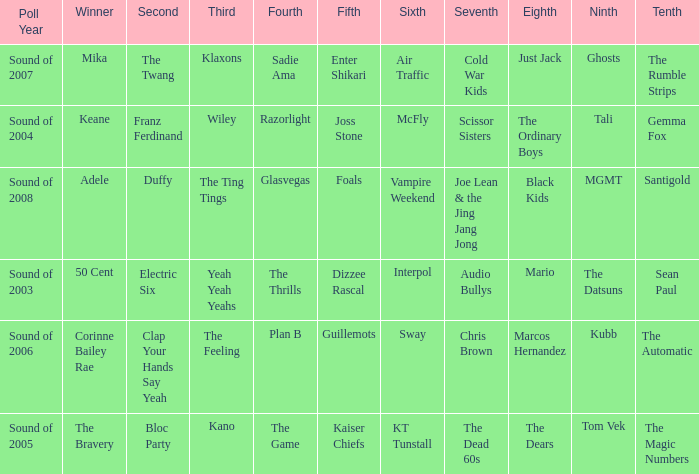When dizzee rascal is 5th, who was the winner? 50 Cent. Write the full table. {'header': ['Poll Year', 'Winner', 'Second', 'Third', 'Fourth', 'Fifth', 'Sixth', 'Seventh', 'Eighth', 'Ninth', 'Tenth'], 'rows': [['Sound of 2007', 'Mika', 'The Twang', 'Klaxons', 'Sadie Ama', 'Enter Shikari', 'Air Traffic', 'Cold War Kids', 'Just Jack', 'Ghosts', 'The Rumble Strips'], ['Sound of 2004', 'Keane', 'Franz Ferdinand', 'Wiley', 'Razorlight', 'Joss Stone', 'McFly', 'Scissor Sisters', 'The Ordinary Boys', 'Tali', 'Gemma Fox'], ['Sound of 2008', 'Adele', 'Duffy', 'The Ting Tings', 'Glasvegas', 'Foals', 'Vampire Weekend', 'Joe Lean & the Jing Jang Jong', 'Black Kids', 'MGMT', 'Santigold'], ['Sound of 2003', '50 Cent', 'Electric Six', 'Yeah Yeah Yeahs', 'The Thrills', 'Dizzee Rascal', 'Interpol', 'Audio Bullys', 'Mario', 'The Datsuns', 'Sean Paul'], ['Sound of 2006', 'Corinne Bailey Rae', 'Clap Your Hands Say Yeah', 'The Feeling', 'Plan B', 'Guillemots', 'Sway', 'Chris Brown', 'Marcos Hernandez', 'Kubb', 'The Automatic'], ['Sound of 2005', 'The Bravery', 'Bloc Party', 'Kano', 'The Game', 'Kaiser Chiefs', 'KT Tunstall', 'The Dead 60s', 'The Dears', 'Tom Vek', 'The Magic Numbers']]} 